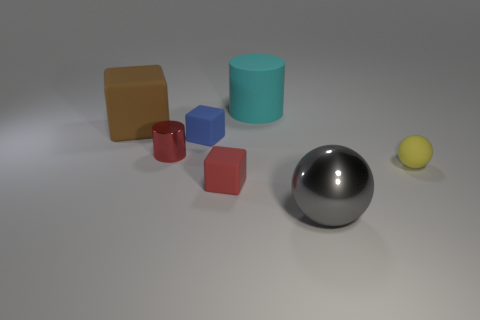Can you describe the texture of the objects in the image? The objects in the image seem to have a variety of textures. The sphere and tall cylinder appear to have reflective, smooth surfaces, hinting at a metallic or polished finish. In contrast, the smaller colored geometric shapes might have a matte surface, suggesting a possible rubber or plastic material. 